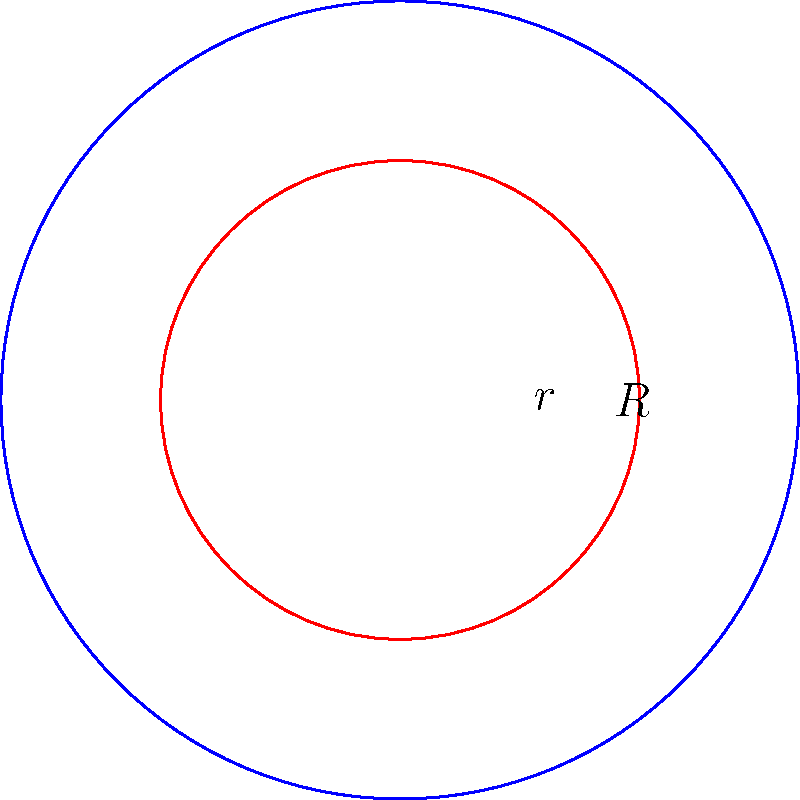In our latest forum discussion about geometric calculations, we encountered an interesting problem. Consider two concentric circles with radii $R = 5$ units and $r = 3$ units, as shown in the diagram. What is the area of the region between these two circles? Let's approach this step-by-step:

1) The area between two concentric circles is the difference between the areas of the larger and smaller circles.

2) Area of a circle is given by the formula $A = \pi r^2$, where $r$ is the radius.

3) For the larger circle:
   $A_1 = \pi R^2 = \pi (5)^2 = 25\pi$ square units

4) For the smaller circle:
   $A_2 = \pi r^2 = \pi (3)^2 = 9\pi$ square units

5) The area between the circles is:
   $A = A_1 - A_2 = 25\pi - 9\pi = 16\pi$ square units

Therefore, the area of the region between the two concentric circles is $16\pi$ square units.
Answer: $16\pi$ square units 